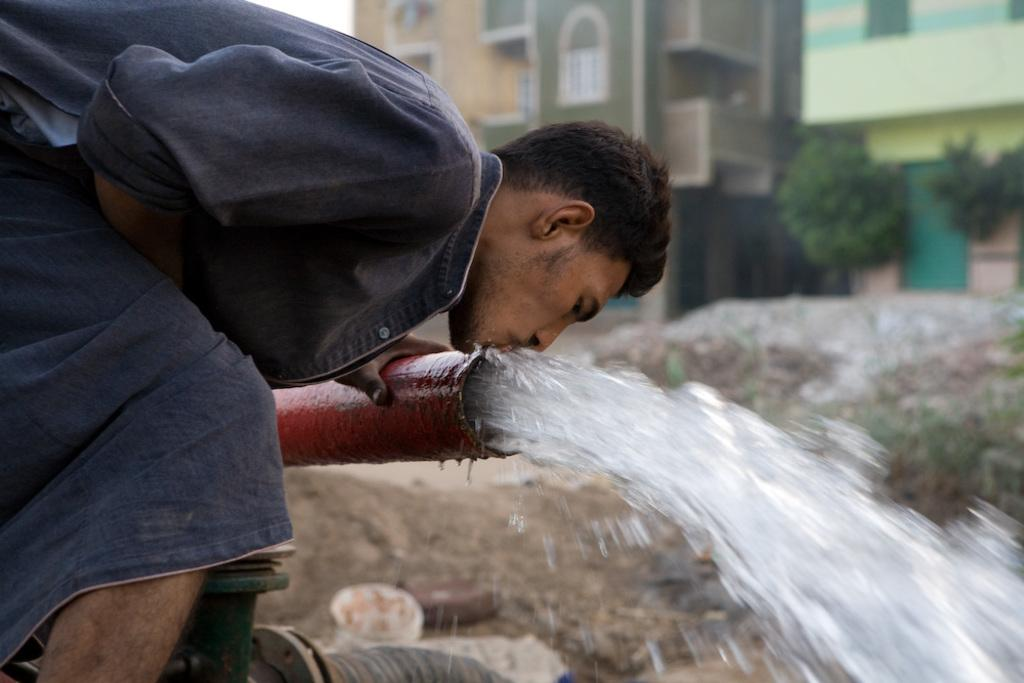What is the main subject of the image? There is a person in the image. What is the person doing in the image? The person is bending and drinking water from a pipe. What can be seen in the background of the image? There are houses and trees in the image. How many snakes are slithering around the person's feet in the image? There are no snakes present in the image. 